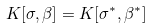Convert formula to latex. <formula><loc_0><loc_0><loc_500><loc_500>K [ \sigma , \beta ] = K [ \sigma ^ { * } , \beta ^ { * } ]</formula> 